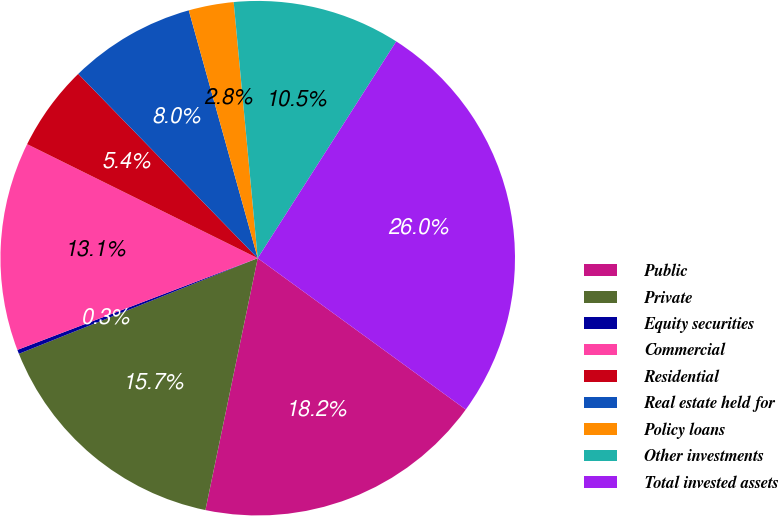Convert chart. <chart><loc_0><loc_0><loc_500><loc_500><pie_chart><fcel>Public<fcel>Private<fcel>Equity securities<fcel>Commercial<fcel>Residential<fcel>Real estate held for<fcel>Policy loans<fcel>Other investments<fcel>Total invested assets<nl><fcel>18.25%<fcel>15.68%<fcel>0.26%<fcel>13.11%<fcel>5.4%<fcel>7.97%<fcel>2.83%<fcel>10.54%<fcel>25.96%<nl></chart> 